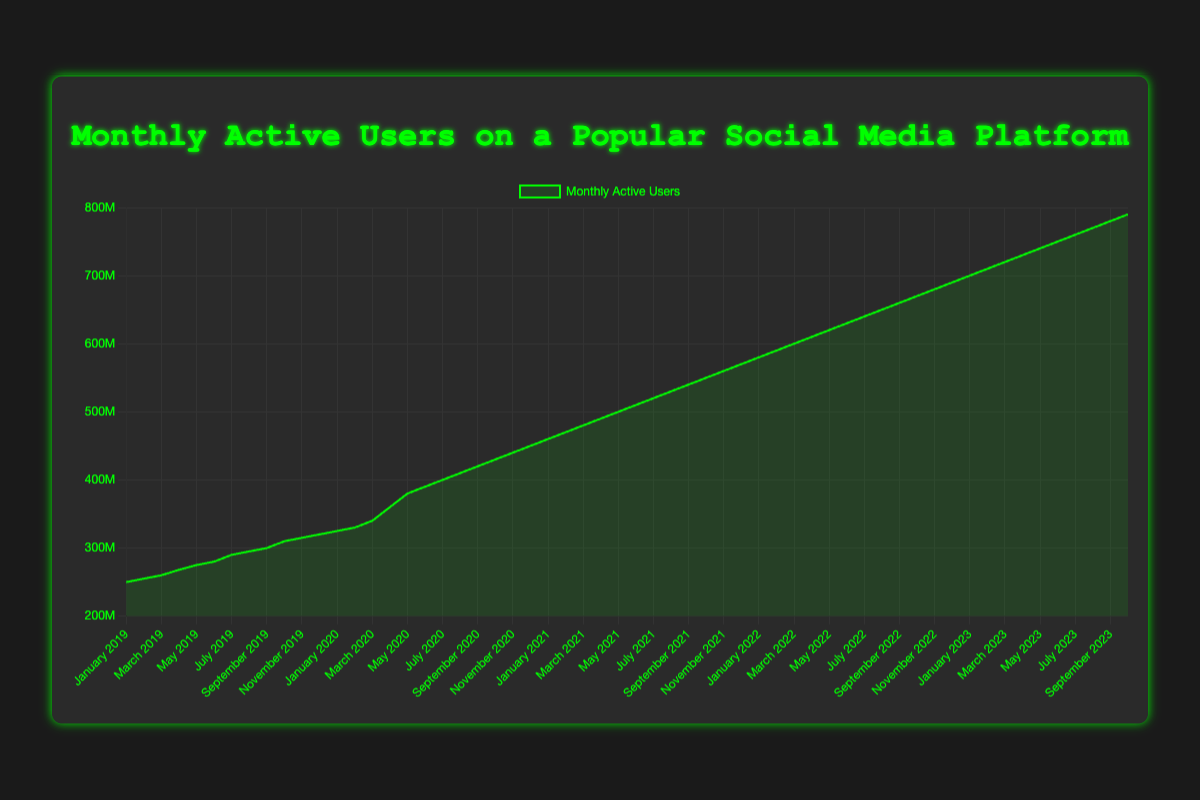What is the trend of monthly active users from January 2019 to October 2023? The number of monthly active users shows an upward trend from January 2019 to October 2023. There are no significant drops in user numbers throughout this period.
Answer: An increasing trend During which year did the monthly active users increase the most? By looking at the steepness of the rise, 2020 shows the largest increase in users within a year, from 325,000,000 in January to 450,000,000 in December.
Answer: 2020 What is the total increase in monthly active users from January 2019 to October 2023? The number of monthly active users in January 2019 is 250,000,000 and in October 2023 it is 790,000,000. The total increase is 790,000,000 - 250,000,000 = 540,000,000.
Answer: 540,000,000 Which month showed the largest single-month increase in monthly active users from January 2019 to October 2023? By examining the largest increases between adjacent months, April 2020 shows the largest single-month increase, rising from 340,000,000 in March 2020 to 360,000,000 in April 2020, an increase of 20,000,000 users.
Answer: April 2020 Comparing the month of June in each year, during which year did June have the highest number of monthly active users? The data for the month of June in each year is: 280,000,000 (2019), 390,000,000 (2020), 510,000,000 (2021), 630,000,000 (2022), and 750,000,000 (2023). 2023 has the highest number of monthly active users.
Answer: 2023 What is the average number of monthly active users for the entire time period from January 2019 to October 2023? First, sum up the monthly active users across all months from January 2019 to October 2023 and divide by the total number of months (58). Summing up these values (250,000,000 + ... + 790,000,000) and then dividing by 58 provides the average.
Answer: (Sum of monthly users) / 58 In which year did the month of December have the highest number of monthly active users? Examining the data for December, the number of active users is: 320,000,000 (2019), 450,000,000 (2020), 570,000,000 (2021), 690,000,000 (2022). Each subsequent year has more users, so 2022 has the highest number.
Answer: 2022 Which year shows the slowest growth rate in the number of monthly active users? Comparing the rise in user numbers in each year, the smallest annual increase is observed in 2019, from 250,000,000 in January to 320,000,000 in December, a total increase of 70,000,000.
Answer: 2019 Describe the visual style of the chart. The chart has a dark theme with a black background and green lines and text. The plot area has a dark gray background, the lines and points are green, and the text and grid lines are colored in shades of gray and green.
Answer: Dark theme with green lines and text 